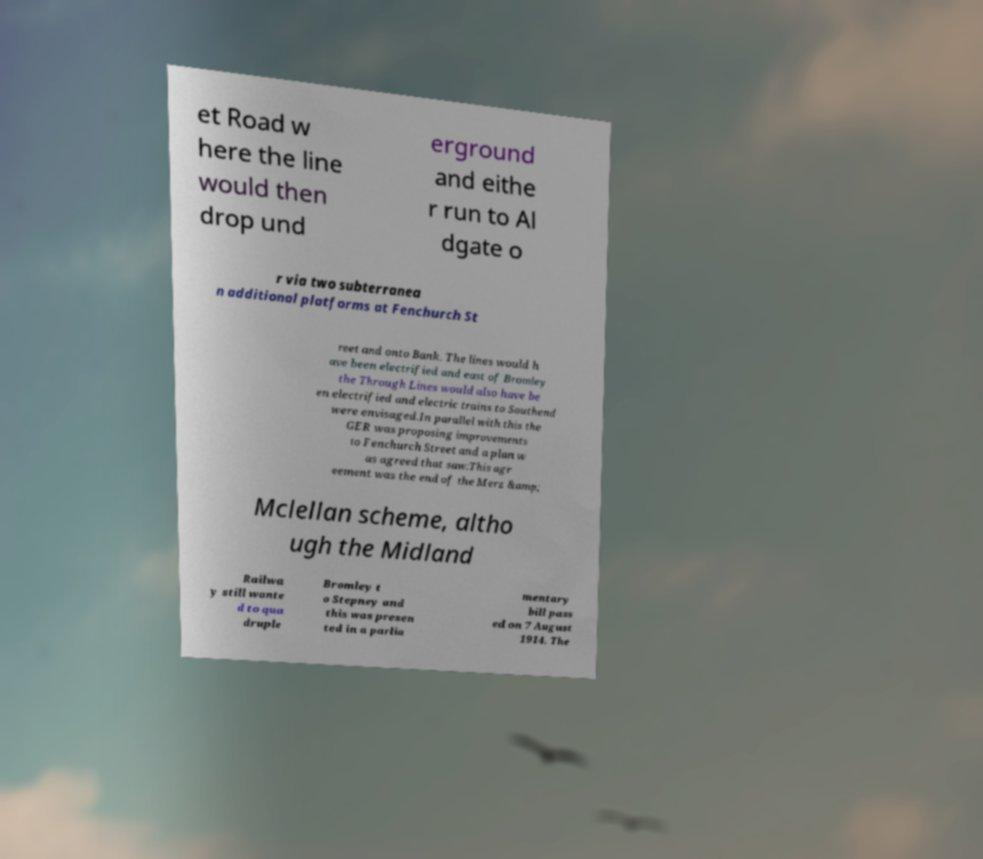Please read and relay the text visible in this image. What does it say? et Road w here the line would then drop und erground and eithe r run to Al dgate o r via two subterranea n additional platforms at Fenchurch St reet and onto Bank. The lines would h ave been electrified and east of Bromley the Through Lines would also have be en electrified and electric trains to Southend were envisaged.In parallel with this the GER was proposing improvements to Fenchurch Street and a plan w as agreed that saw:This agr eement was the end of the Merz &amp; Mclellan scheme, altho ugh the Midland Railwa y still wante d to qua druple Bromley t o Stepney and this was presen ted in a parlia mentary bill pass ed on 7 August 1914. The 